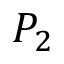<formula> <loc_0><loc_0><loc_500><loc_500>P _ { 2 }</formula> 